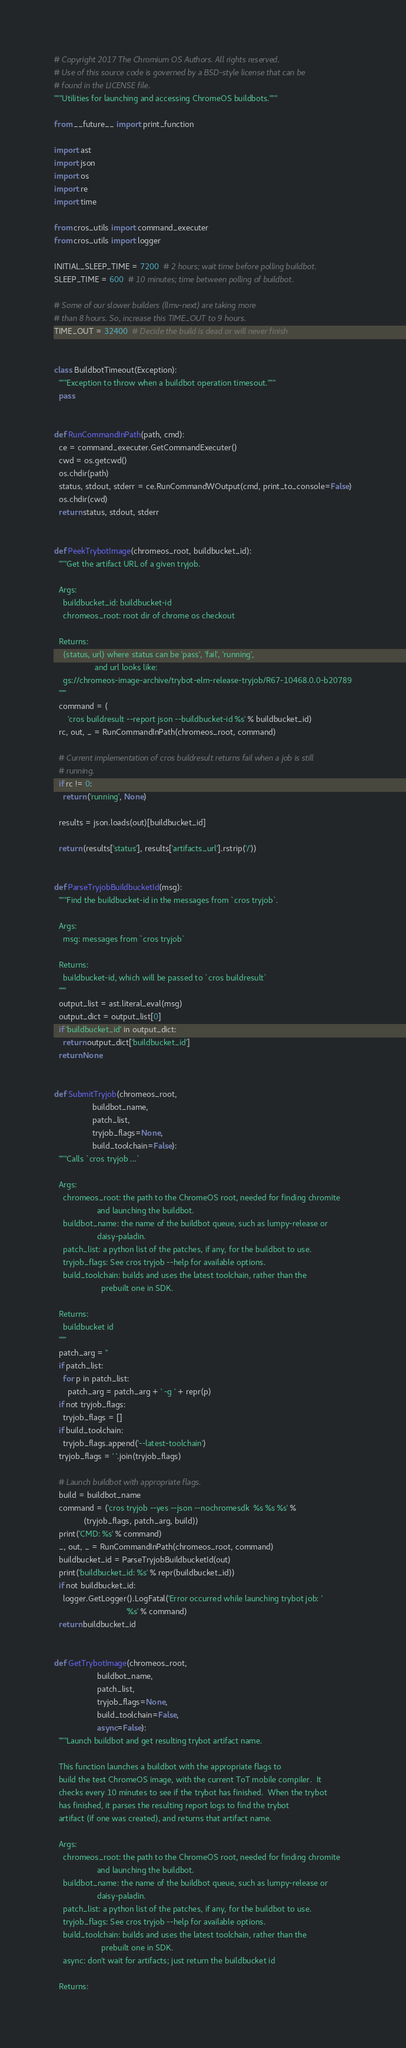<code> <loc_0><loc_0><loc_500><loc_500><_Python_># Copyright 2017 The Chromium OS Authors. All rights reserved.
# Use of this source code is governed by a BSD-style license that can be
# found in the LICENSE file.
"""Utilities for launching and accessing ChromeOS buildbots."""

from __future__ import print_function

import ast
import json
import os
import re
import time

from cros_utils import command_executer
from cros_utils import logger

INITIAL_SLEEP_TIME = 7200  # 2 hours; wait time before polling buildbot.
SLEEP_TIME = 600  # 10 minutes; time between polling of buildbot.

# Some of our slower builders (llmv-next) are taking more
# than 8 hours. So, increase this TIME_OUT to 9 hours.
TIME_OUT = 32400  # Decide the build is dead or will never finish


class BuildbotTimeout(Exception):
  """Exception to throw when a buildbot operation timesout."""
  pass


def RunCommandInPath(path, cmd):
  ce = command_executer.GetCommandExecuter()
  cwd = os.getcwd()
  os.chdir(path)
  status, stdout, stderr = ce.RunCommandWOutput(cmd, print_to_console=False)
  os.chdir(cwd)
  return status, stdout, stderr


def PeekTrybotImage(chromeos_root, buildbucket_id):
  """Get the artifact URL of a given tryjob.

  Args:
    buildbucket_id: buildbucket-id
    chromeos_root: root dir of chrome os checkout

  Returns:
    (status, url) where status can be 'pass', 'fail', 'running',
                  and url looks like:
    gs://chromeos-image-archive/trybot-elm-release-tryjob/R67-10468.0.0-b20789
  """
  command = (
      'cros buildresult --report json --buildbucket-id %s' % buildbucket_id)
  rc, out, _ = RunCommandInPath(chromeos_root, command)

  # Current implementation of cros buildresult returns fail when a job is still
  # running.
  if rc != 0:
    return ('running', None)

  results = json.loads(out)[buildbucket_id]

  return (results['status'], results['artifacts_url'].rstrip('/'))


def ParseTryjobBuildbucketId(msg):
  """Find the buildbucket-id in the messages from `cros tryjob`.

  Args:
    msg: messages from `cros tryjob`

  Returns:
    buildbucket-id, which will be passed to `cros buildresult`
  """
  output_list = ast.literal_eval(msg)
  output_dict = output_list[0]
  if 'buildbucket_id' in output_dict:
    return output_dict['buildbucket_id']
  return None


def SubmitTryjob(chromeos_root,
                 buildbot_name,
                 patch_list,
                 tryjob_flags=None,
                 build_toolchain=False):
  """Calls `cros tryjob ...`

  Args:
    chromeos_root: the path to the ChromeOS root, needed for finding chromite
                   and launching the buildbot.
    buildbot_name: the name of the buildbot queue, such as lumpy-release or
                   daisy-paladin.
    patch_list: a python list of the patches, if any, for the buildbot to use.
    tryjob_flags: See cros tryjob --help for available options.
    build_toolchain: builds and uses the latest toolchain, rather than the
                     prebuilt one in SDK.

  Returns:
    buildbucket id
  """
  patch_arg = ''
  if patch_list:
    for p in patch_list:
      patch_arg = patch_arg + ' -g ' + repr(p)
  if not tryjob_flags:
    tryjob_flags = []
  if build_toolchain:
    tryjob_flags.append('--latest-toolchain')
  tryjob_flags = ' '.join(tryjob_flags)

  # Launch buildbot with appropriate flags.
  build = buildbot_name
  command = ('cros tryjob --yes --json --nochromesdk  %s %s %s' %
             (tryjob_flags, patch_arg, build))
  print('CMD: %s' % command)
  _, out, _ = RunCommandInPath(chromeos_root, command)
  buildbucket_id = ParseTryjobBuildbucketId(out)
  print('buildbucket_id: %s' % repr(buildbucket_id))
  if not buildbucket_id:
    logger.GetLogger().LogFatal('Error occurred while launching trybot job: '
                                '%s' % command)
  return buildbucket_id


def GetTrybotImage(chromeos_root,
                   buildbot_name,
                   patch_list,
                   tryjob_flags=None,
                   build_toolchain=False,
                   async=False):
  """Launch buildbot and get resulting trybot artifact name.

  This function launches a buildbot with the appropriate flags to
  build the test ChromeOS image, with the current ToT mobile compiler.  It
  checks every 10 minutes to see if the trybot has finished.  When the trybot
  has finished, it parses the resulting report logs to find the trybot
  artifact (if one was created), and returns that artifact name.

  Args:
    chromeos_root: the path to the ChromeOS root, needed for finding chromite
                   and launching the buildbot.
    buildbot_name: the name of the buildbot queue, such as lumpy-release or
                   daisy-paladin.
    patch_list: a python list of the patches, if any, for the buildbot to use.
    tryjob_flags: See cros tryjob --help for available options.
    build_toolchain: builds and uses the latest toolchain, rather than the
                     prebuilt one in SDK.
    async: don't wait for artifacts; just return the buildbucket id

  Returns:</code> 